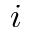<formula> <loc_0><loc_0><loc_500><loc_500>i</formula> 